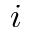<formula> <loc_0><loc_0><loc_500><loc_500>i</formula> 